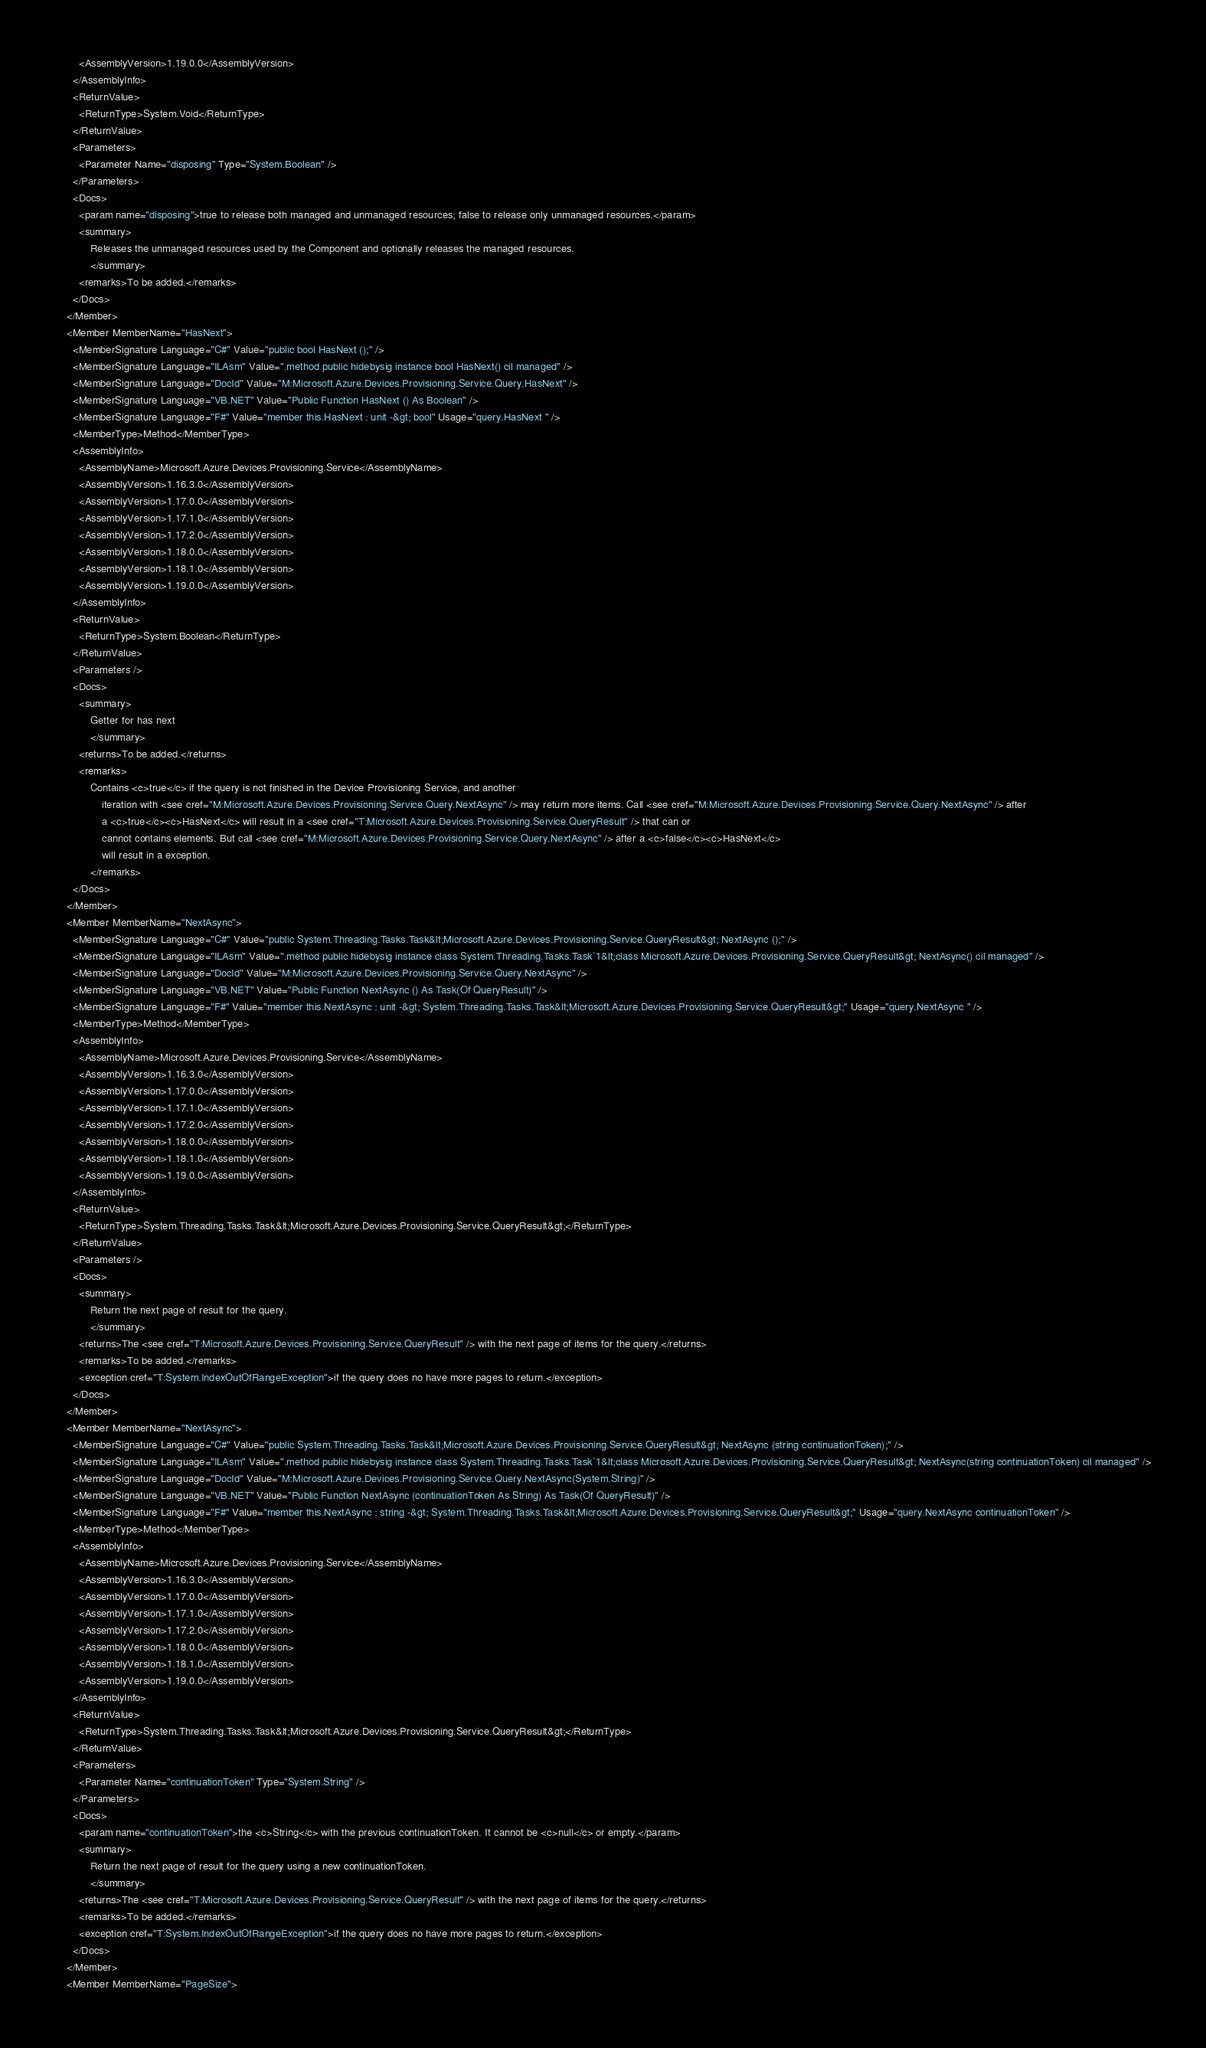<code> <loc_0><loc_0><loc_500><loc_500><_XML_>        <AssemblyVersion>1.19.0.0</AssemblyVersion>
      </AssemblyInfo>
      <ReturnValue>
        <ReturnType>System.Void</ReturnType>
      </ReturnValue>
      <Parameters>
        <Parameter Name="disposing" Type="System.Boolean" />
      </Parameters>
      <Docs>
        <param name="disposing">true to release both managed and unmanaged resources; false to release only unmanaged resources.</param>
        <summary>
            Releases the unmanaged resources used by the Component and optionally releases the managed resources.
            </summary>
        <remarks>To be added.</remarks>
      </Docs>
    </Member>
    <Member MemberName="HasNext">
      <MemberSignature Language="C#" Value="public bool HasNext ();" />
      <MemberSignature Language="ILAsm" Value=".method public hidebysig instance bool HasNext() cil managed" />
      <MemberSignature Language="DocId" Value="M:Microsoft.Azure.Devices.Provisioning.Service.Query.HasNext" />
      <MemberSignature Language="VB.NET" Value="Public Function HasNext () As Boolean" />
      <MemberSignature Language="F#" Value="member this.HasNext : unit -&gt; bool" Usage="query.HasNext " />
      <MemberType>Method</MemberType>
      <AssemblyInfo>
        <AssemblyName>Microsoft.Azure.Devices.Provisioning.Service</AssemblyName>
        <AssemblyVersion>1.16.3.0</AssemblyVersion>
        <AssemblyVersion>1.17.0.0</AssemblyVersion>
        <AssemblyVersion>1.17.1.0</AssemblyVersion>
        <AssemblyVersion>1.17.2.0</AssemblyVersion>
        <AssemblyVersion>1.18.0.0</AssemblyVersion>
        <AssemblyVersion>1.18.1.0</AssemblyVersion>
        <AssemblyVersion>1.19.0.0</AssemblyVersion>
      </AssemblyInfo>
      <ReturnValue>
        <ReturnType>System.Boolean</ReturnType>
      </ReturnValue>
      <Parameters />
      <Docs>
        <summary>
            Getter for has next
            </summary>
        <returns>To be added.</returns>
        <remarks>
            Contains <c>true</c> if the query is not finished in the Device Provisioning Service, and another
                iteration with <see cref="M:Microsoft.Azure.Devices.Provisioning.Service.Query.NextAsync" /> may return more items. Call <see cref="M:Microsoft.Azure.Devices.Provisioning.Service.Query.NextAsync" /> after 
                a <c>true</c><c>HasNext</c> will result in a <see cref="T:Microsoft.Azure.Devices.Provisioning.Service.QueryResult" /> that can or 
                cannot contains elements. But call <see cref="M:Microsoft.Azure.Devices.Provisioning.Service.Query.NextAsync" /> after a <c>false</c><c>HasNext</c> 
                will result in a exception.
            </remarks>
      </Docs>
    </Member>
    <Member MemberName="NextAsync">
      <MemberSignature Language="C#" Value="public System.Threading.Tasks.Task&lt;Microsoft.Azure.Devices.Provisioning.Service.QueryResult&gt; NextAsync ();" />
      <MemberSignature Language="ILAsm" Value=".method public hidebysig instance class System.Threading.Tasks.Task`1&lt;class Microsoft.Azure.Devices.Provisioning.Service.QueryResult&gt; NextAsync() cil managed" />
      <MemberSignature Language="DocId" Value="M:Microsoft.Azure.Devices.Provisioning.Service.Query.NextAsync" />
      <MemberSignature Language="VB.NET" Value="Public Function NextAsync () As Task(Of QueryResult)" />
      <MemberSignature Language="F#" Value="member this.NextAsync : unit -&gt; System.Threading.Tasks.Task&lt;Microsoft.Azure.Devices.Provisioning.Service.QueryResult&gt;" Usage="query.NextAsync " />
      <MemberType>Method</MemberType>
      <AssemblyInfo>
        <AssemblyName>Microsoft.Azure.Devices.Provisioning.Service</AssemblyName>
        <AssemblyVersion>1.16.3.0</AssemblyVersion>
        <AssemblyVersion>1.17.0.0</AssemblyVersion>
        <AssemblyVersion>1.17.1.0</AssemblyVersion>
        <AssemblyVersion>1.17.2.0</AssemblyVersion>
        <AssemblyVersion>1.18.0.0</AssemblyVersion>
        <AssemblyVersion>1.18.1.0</AssemblyVersion>
        <AssemblyVersion>1.19.0.0</AssemblyVersion>
      </AssemblyInfo>
      <ReturnValue>
        <ReturnType>System.Threading.Tasks.Task&lt;Microsoft.Azure.Devices.Provisioning.Service.QueryResult&gt;</ReturnType>
      </ReturnValue>
      <Parameters />
      <Docs>
        <summary>
            Return the next page of result for the query.
            </summary>
        <returns>The <see cref="T:Microsoft.Azure.Devices.Provisioning.Service.QueryResult" /> with the next page of items for the query.</returns>
        <remarks>To be added.</remarks>
        <exception cref="T:System.IndexOutOfRangeException">if the query does no have more pages to return.</exception>
      </Docs>
    </Member>
    <Member MemberName="NextAsync">
      <MemberSignature Language="C#" Value="public System.Threading.Tasks.Task&lt;Microsoft.Azure.Devices.Provisioning.Service.QueryResult&gt; NextAsync (string continuationToken);" />
      <MemberSignature Language="ILAsm" Value=".method public hidebysig instance class System.Threading.Tasks.Task`1&lt;class Microsoft.Azure.Devices.Provisioning.Service.QueryResult&gt; NextAsync(string continuationToken) cil managed" />
      <MemberSignature Language="DocId" Value="M:Microsoft.Azure.Devices.Provisioning.Service.Query.NextAsync(System.String)" />
      <MemberSignature Language="VB.NET" Value="Public Function NextAsync (continuationToken As String) As Task(Of QueryResult)" />
      <MemberSignature Language="F#" Value="member this.NextAsync : string -&gt; System.Threading.Tasks.Task&lt;Microsoft.Azure.Devices.Provisioning.Service.QueryResult&gt;" Usage="query.NextAsync continuationToken" />
      <MemberType>Method</MemberType>
      <AssemblyInfo>
        <AssemblyName>Microsoft.Azure.Devices.Provisioning.Service</AssemblyName>
        <AssemblyVersion>1.16.3.0</AssemblyVersion>
        <AssemblyVersion>1.17.0.0</AssemblyVersion>
        <AssemblyVersion>1.17.1.0</AssemblyVersion>
        <AssemblyVersion>1.17.2.0</AssemblyVersion>
        <AssemblyVersion>1.18.0.0</AssemblyVersion>
        <AssemblyVersion>1.18.1.0</AssemblyVersion>
        <AssemblyVersion>1.19.0.0</AssemblyVersion>
      </AssemblyInfo>
      <ReturnValue>
        <ReturnType>System.Threading.Tasks.Task&lt;Microsoft.Azure.Devices.Provisioning.Service.QueryResult&gt;</ReturnType>
      </ReturnValue>
      <Parameters>
        <Parameter Name="continuationToken" Type="System.String" />
      </Parameters>
      <Docs>
        <param name="continuationToken">the <c>String</c> with the previous continuationToken. It cannot be <c>null</c> or empty.</param>
        <summary>
            Return the next page of result for the query using a new continuationToken.
            </summary>
        <returns>The <see cref="T:Microsoft.Azure.Devices.Provisioning.Service.QueryResult" /> with the next page of items for the query.</returns>
        <remarks>To be added.</remarks>
        <exception cref="T:System.IndexOutOfRangeException">if the query does no have more pages to return.</exception>
      </Docs>
    </Member>
    <Member MemberName="PageSize"></code> 